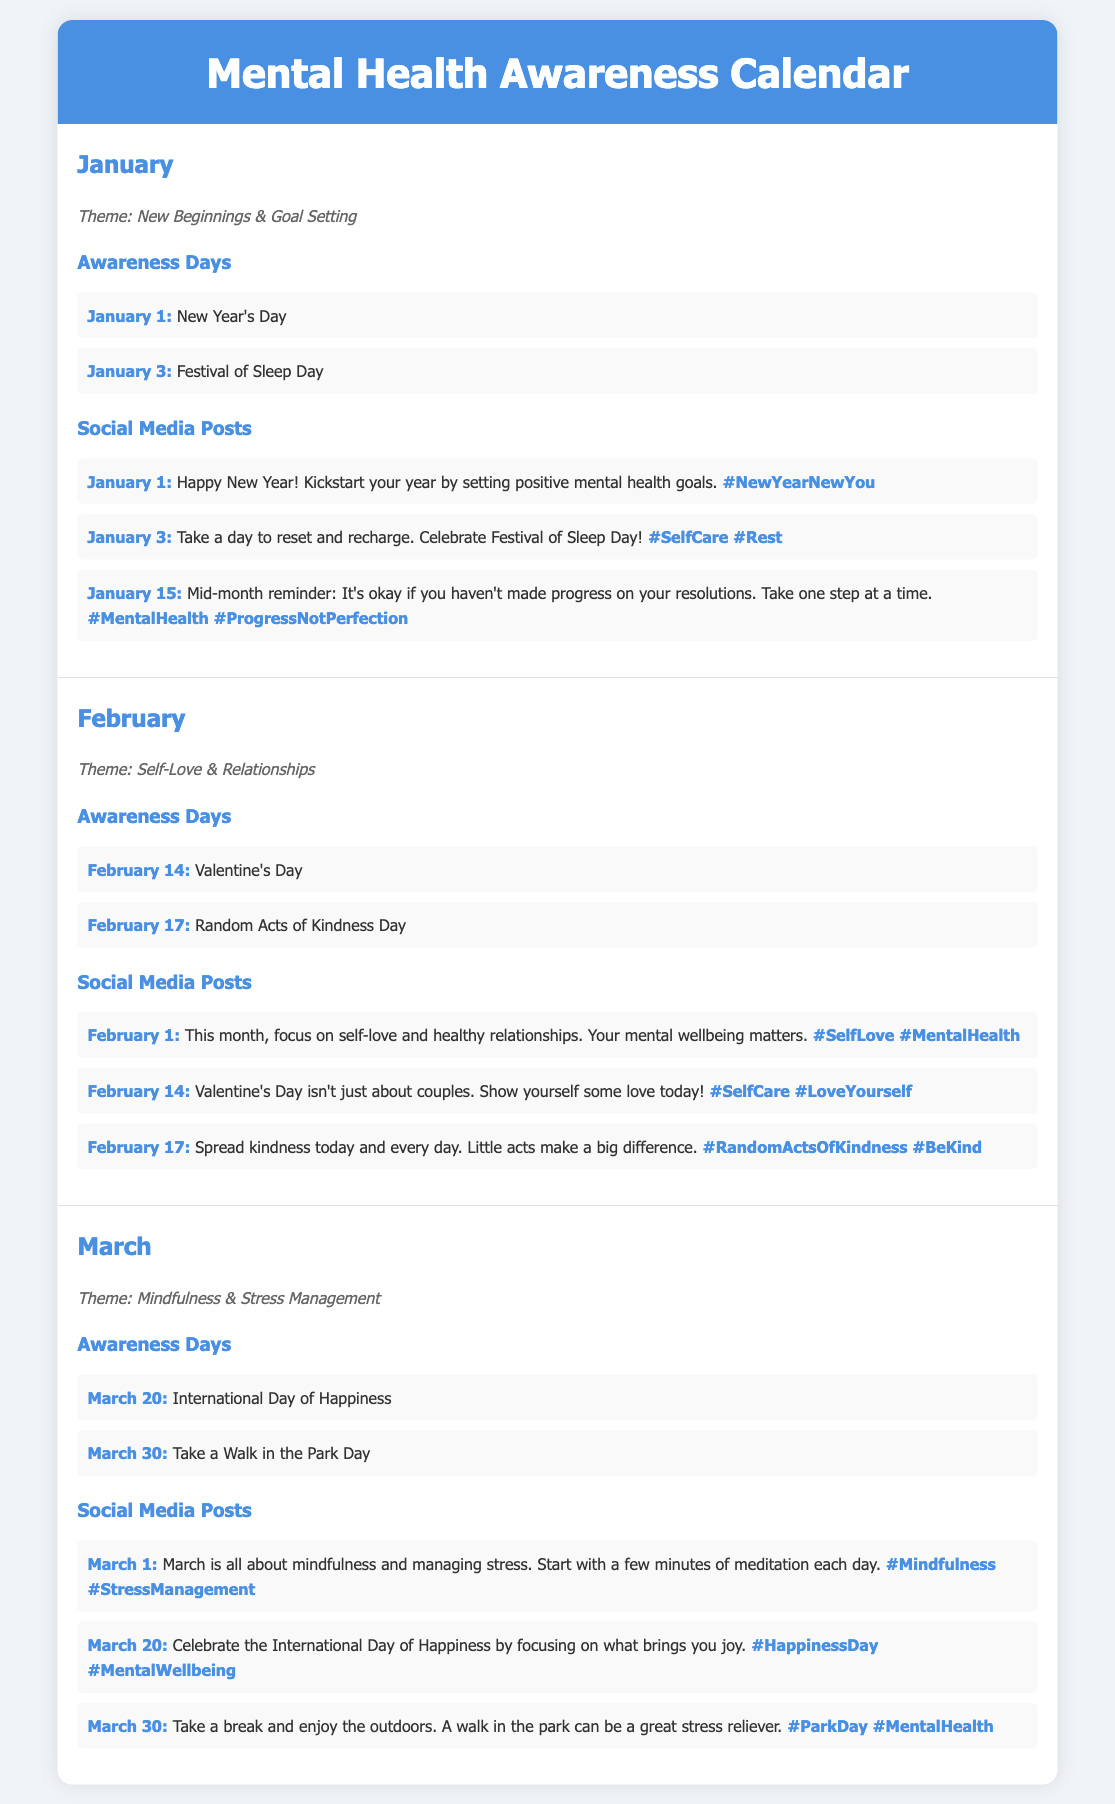What is the theme for January? The theme is specified under the month of January in the document.
Answer: New Beginnings & Goal Setting What date is Valentine's Day? Valentine's Day is listed under the awareness days for February.
Answer: February 14 How many awareness days are mentioned for March? The number of awareness days is found by counting the entries listed for March.
Answer: 2 What is the hashtag associated with Random Acts of Kindness Day? The hashtag is found in the social media posts related to February 17.
Answer: #RandomActsOfKindness #BeKind Which awareness day is celebrated on March 20? This information can be retrieved from the awareness days section for March.
Answer: International Day of Happiness What is the first social media post date in February? The date is found at the beginning of the social media posts for February.
Answer: February 1 What mental health aspect is emphasized in March? The document specifies a focus for March under the theme section.
Answer: Mindfulness & Stress Management How are social media posts categorized in the document? The organization of posts is indicated in the structure of the document regarding content types.
Answer: By month What is the last date listed for January social media posts? The last entry in January's social media posts provides this information.
Answer: January 15 